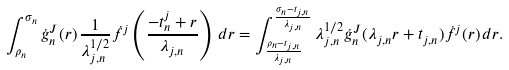Convert formula to latex. <formula><loc_0><loc_0><loc_500><loc_500>\int _ { \rho _ { n } } ^ { \sigma _ { n } } \dot { g } _ { n } ^ { J } ( r ) \, \frac { 1 } { \lambda _ { j , n } ^ { 1 / 2 } } \dot { f } ^ { j } \left ( \frac { - t _ { n } ^ { j } + r } { \lambda _ { j , n } } \right ) \, d r = \int _ { \frac { \rho _ { n } - t _ { j , n } } { \lambda _ { j , n } } } ^ { \frac { \sigma _ { n } - t _ { j , n } } { \lambda _ { j , n } } } \lambda _ { j , n } ^ { 1 / 2 } \dot { g } ^ { J } _ { n } ( \lambda _ { j , n } r + t _ { j , n } ) \dot { f } ^ { j } ( r ) \, d r .</formula> 